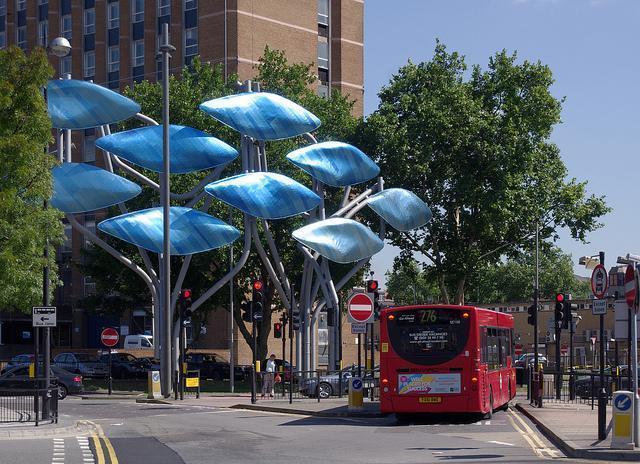What type of art is this?
From the following set of four choices, select the accurate answer to respond to the question.
Options: Sand, painting, drawing, sculpture. Sculpture. 